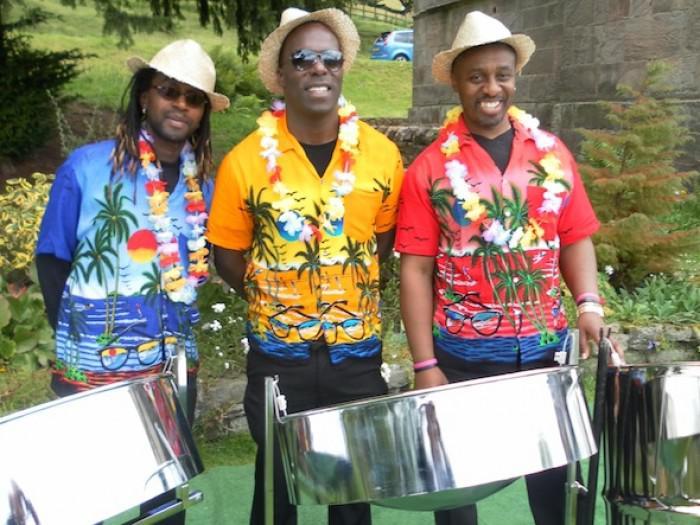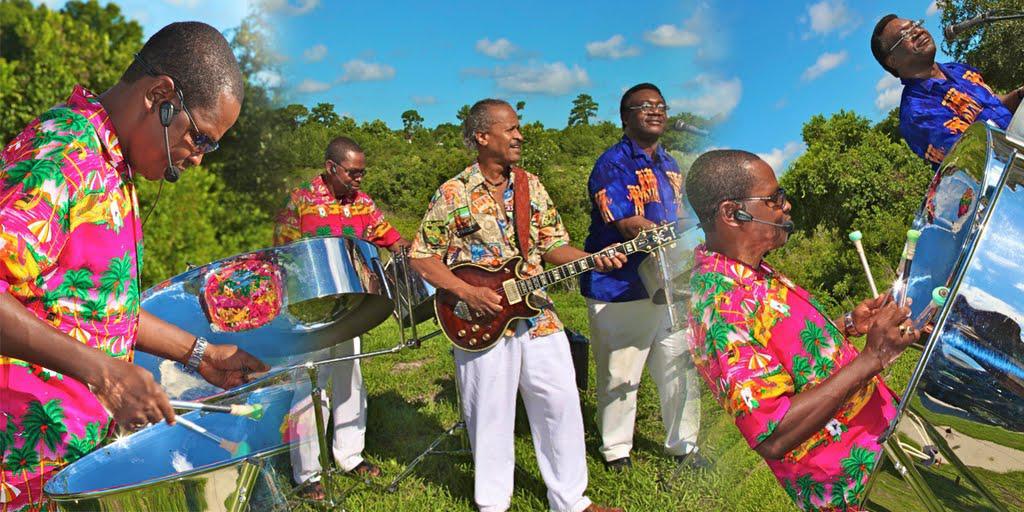The first image is the image on the left, the second image is the image on the right. Given the left and right images, does the statement "Some musicians are wearing hats." hold true? Answer yes or no. Yes. The first image is the image on the left, the second image is the image on the right. Evaluate the accuracy of this statement regarding the images: "Each image includes at least three men standing behind drums, and at least one man in each image is wearing a hawaiian shirt.". Is it true? Answer yes or no. Yes. 